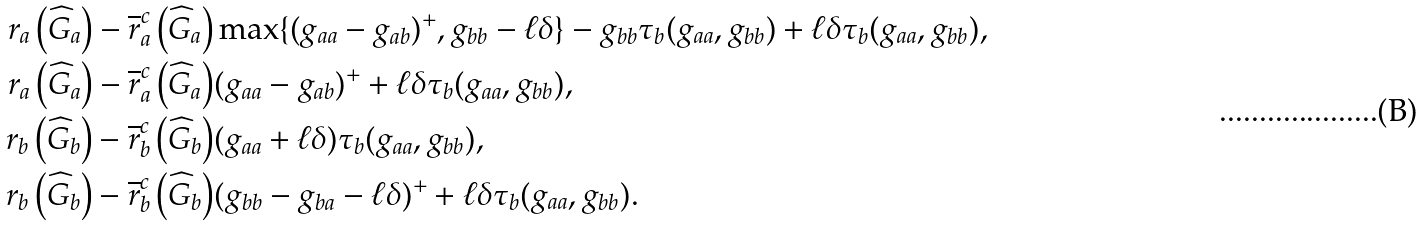<formula> <loc_0><loc_0><loc_500><loc_500>r _ { a } \left ( \widehat { G } _ { a } \right ) - \overline { r } _ { a } ^ { c } \left ( \widehat { G } _ { a } \right ) & \max \{ ( g _ { a a } - g _ { a b } ) ^ { + } , g _ { b b } - \ell \delta \} - g _ { b b } \tau _ { b } ( g _ { a a } , g _ { b b } ) + \ell \delta \tau _ { b } ( g _ { a a } , g _ { b b } ) , \\ r _ { a } \left ( \widehat { G } _ { a } \right ) - \overline { r } _ { a } ^ { c } \left ( \widehat { G } _ { a } \right ) & ( g _ { a a } - g _ { a b } ) ^ { + } + \ell \delta \tau _ { b } ( g _ { a a } , g _ { b b } ) , \\ r _ { b } \left ( \widehat { G } _ { b } \right ) - \overline { r } _ { b } ^ { c } \left ( \widehat { G } _ { b } \right ) & ( g _ { a a } + \ell \delta ) \tau _ { b } ( g _ { a a } , g _ { b b } ) , \\ r _ { b } \left ( \widehat { G } _ { b } \right ) - \overline { r } _ { b } ^ { c } \left ( \widehat { G } _ { b } \right ) & ( g _ { b b } - g _ { b a } - \ell \delta ) ^ { + } + \ell \delta \tau _ { b } ( g _ { a a } , g _ { b b } ) .</formula> 